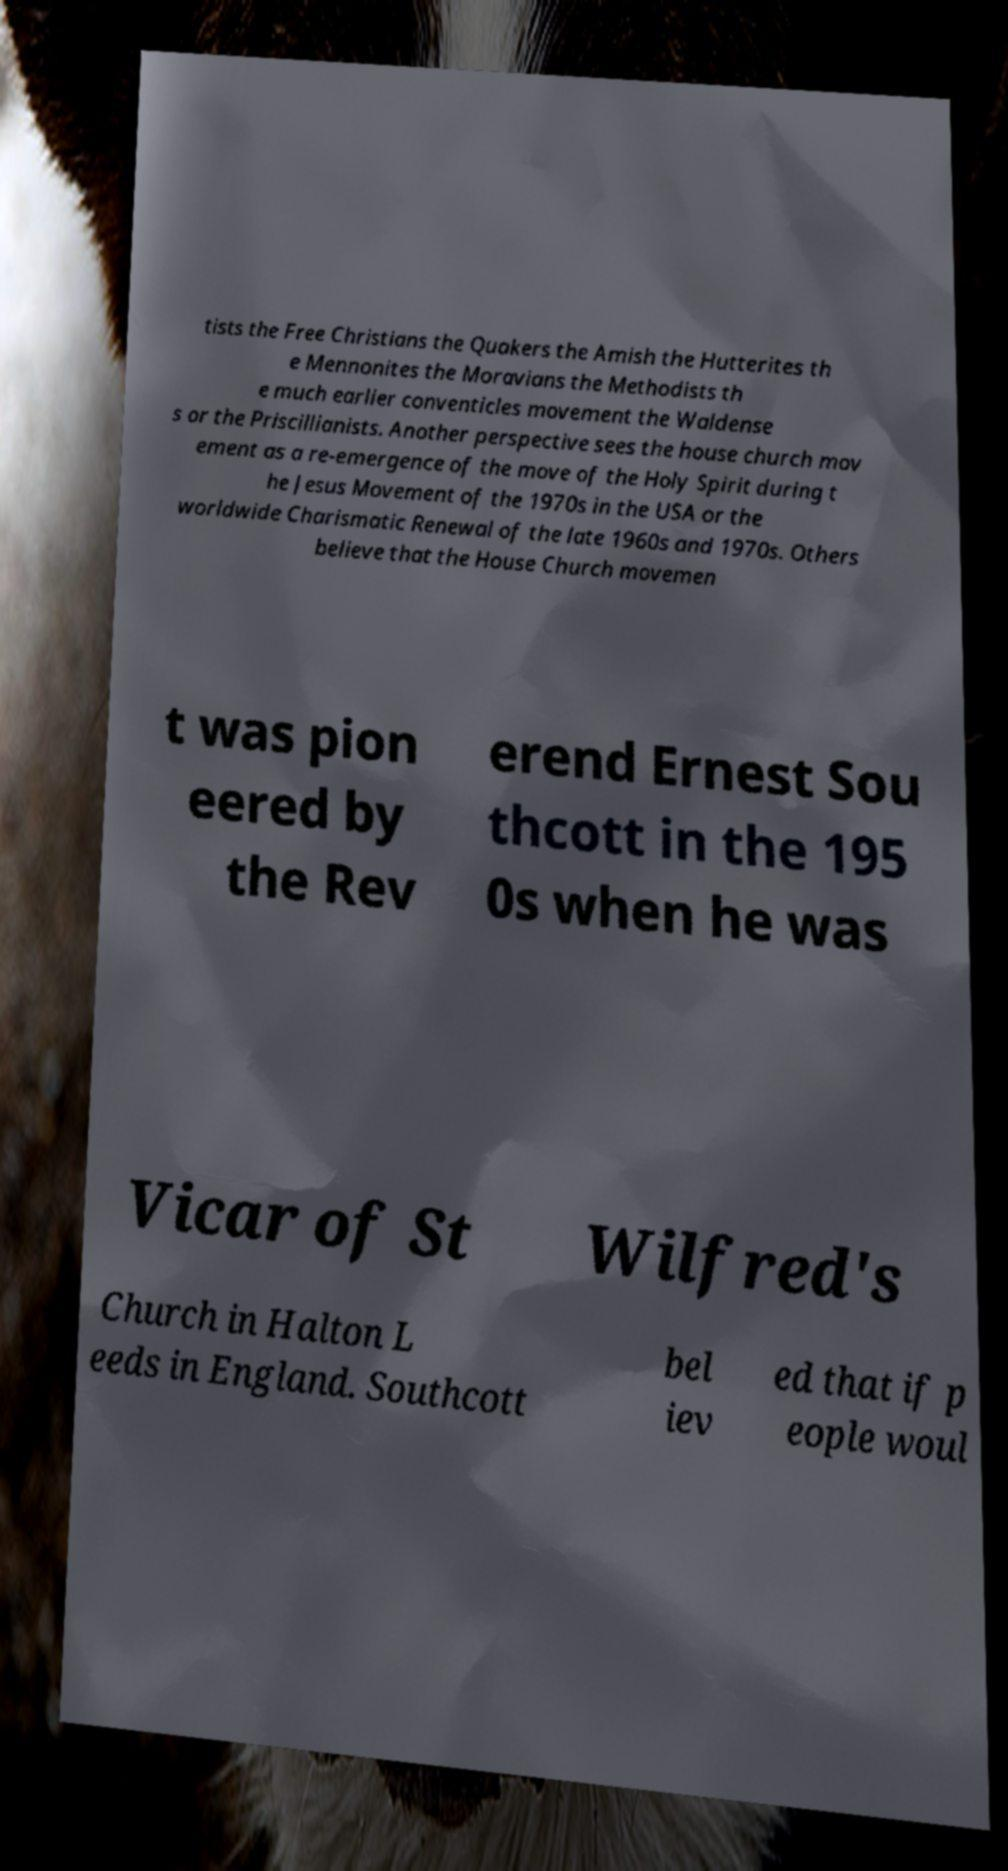Could you extract and type out the text from this image? tists the Free Christians the Quakers the Amish the Hutterites th e Mennonites the Moravians the Methodists th e much earlier conventicles movement the Waldense s or the Priscillianists. Another perspective sees the house church mov ement as a re-emergence of the move of the Holy Spirit during t he Jesus Movement of the 1970s in the USA or the worldwide Charismatic Renewal of the late 1960s and 1970s. Others believe that the House Church movemen t was pion eered by the Rev erend Ernest Sou thcott in the 195 0s when he was Vicar of St Wilfred's Church in Halton L eeds in England. Southcott bel iev ed that if p eople woul 